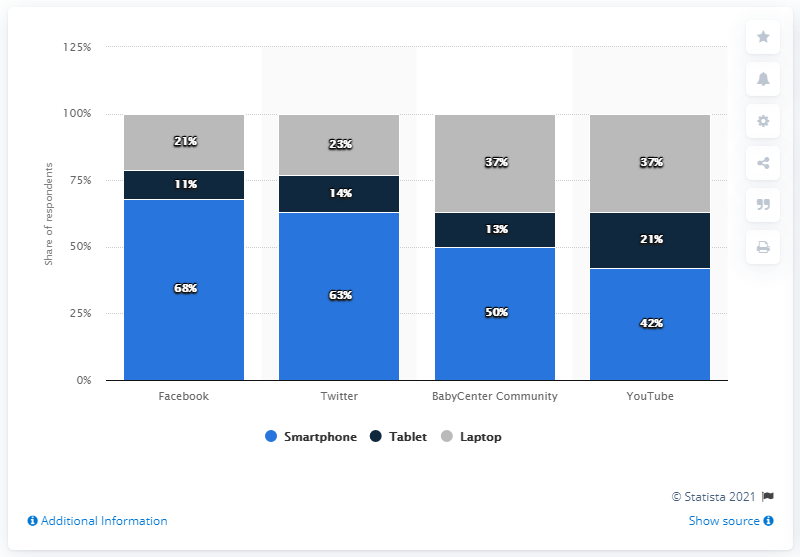Give some essential details in this illustration. The device that is represented by grey color is the laptop. YouTube is less than Babycenter community by approximately 8%. 